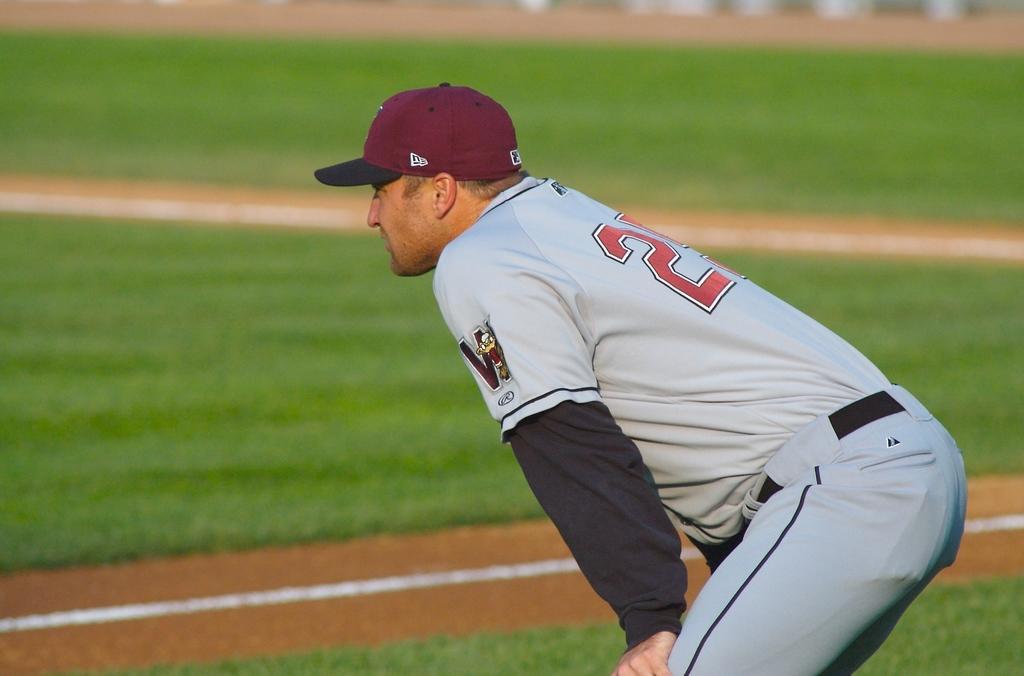Describe this image in one or two sentences. As we can see in the image there is grass, a man wearing cap and white color dress. 